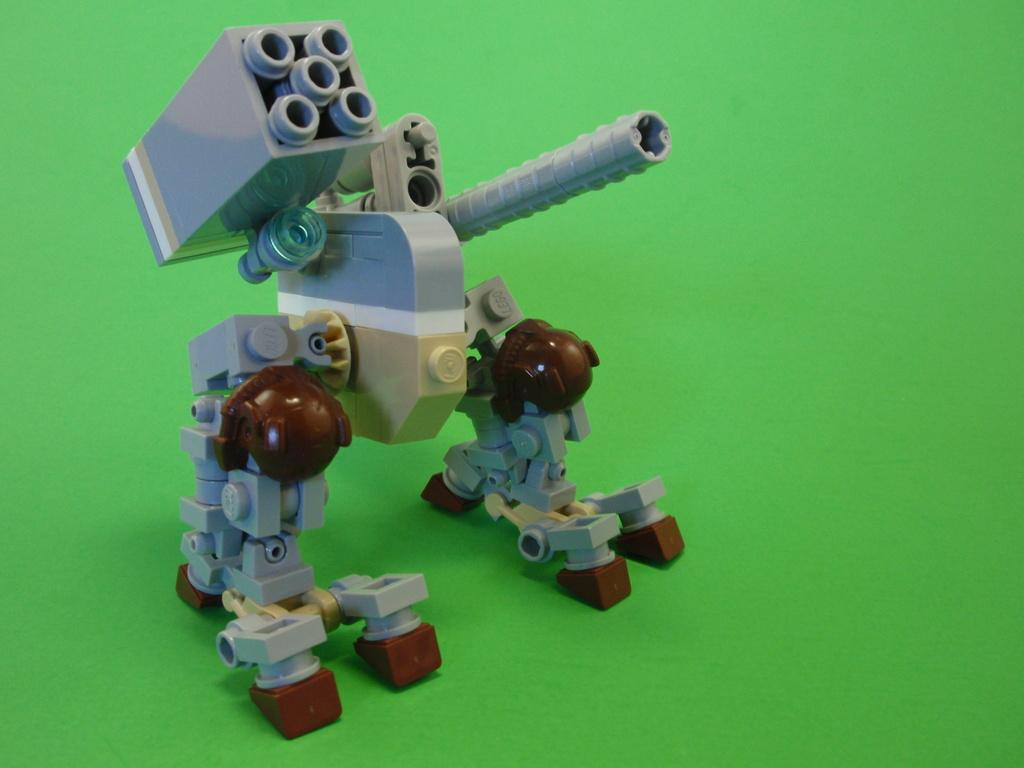What is the main subject of the image? The main subject of the image is a robot. How was the robot created? The robot is made with Legos. What place does the robot visit in the image? There is no indication of a specific place in the image, as it only features a Lego robot. How does the robot look in the image? The robot looks like it is made with Legos, as mentioned in the facts. 